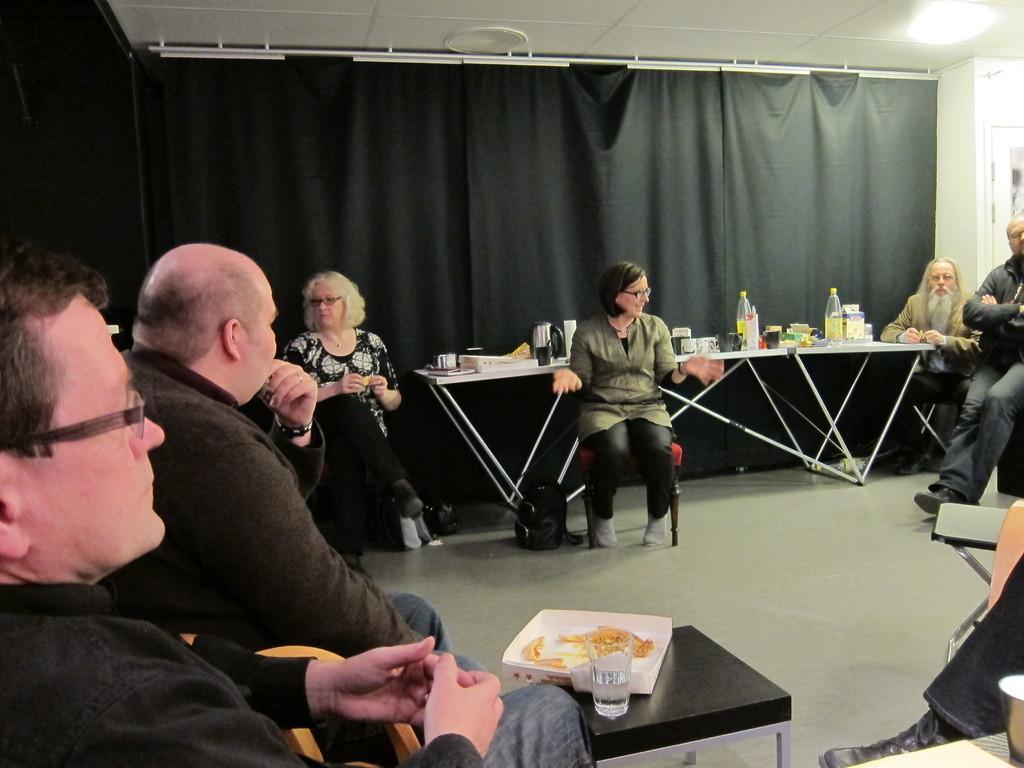Could you give a brief overview of what you see in this image? This picture describes about group of people they are all seated on the chair, in front of them we can find couple of glasses, bottles, and box on the table, and also we can see some baggage and curtains. 